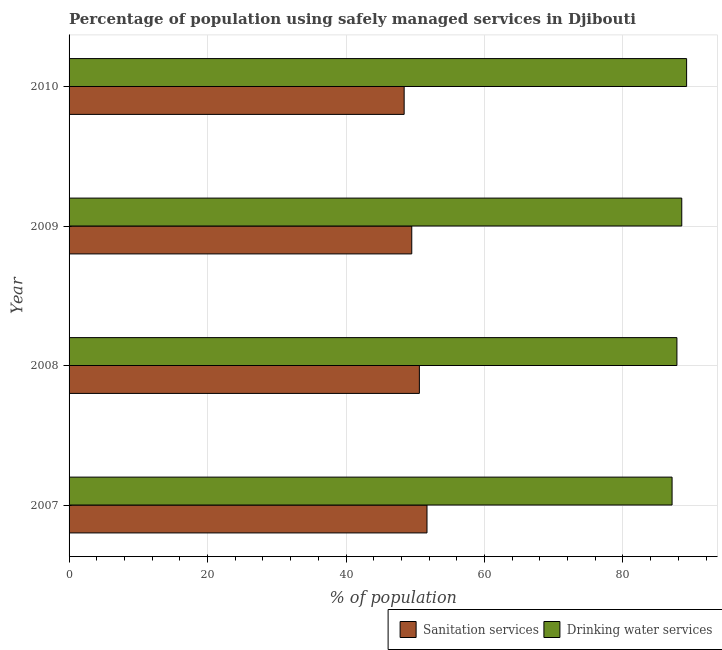How many groups of bars are there?
Give a very brief answer. 4. Are the number of bars per tick equal to the number of legend labels?
Ensure brevity in your answer.  Yes. Are the number of bars on each tick of the Y-axis equal?
Your answer should be compact. Yes. How many bars are there on the 3rd tick from the top?
Offer a terse response. 2. How many bars are there on the 1st tick from the bottom?
Your response must be concise. 2. What is the label of the 3rd group of bars from the top?
Keep it short and to the point. 2008. What is the percentage of population who used sanitation services in 2007?
Ensure brevity in your answer.  51.7. Across all years, what is the maximum percentage of population who used drinking water services?
Offer a very short reply. 89.2. Across all years, what is the minimum percentage of population who used drinking water services?
Your response must be concise. 87.1. In which year was the percentage of population who used sanitation services maximum?
Provide a short and direct response. 2007. What is the total percentage of population who used drinking water services in the graph?
Keep it short and to the point. 352.6. What is the difference between the percentage of population who used drinking water services in 2010 and the percentage of population who used sanitation services in 2007?
Your response must be concise. 37.5. What is the average percentage of population who used sanitation services per year?
Offer a terse response. 50.05. In the year 2008, what is the difference between the percentage of population who used sanitation services and percentage of population who used drinking water services?
Give a very brief answer. -37.2. What is the ratio of the percentage of population who used sanitation services in 2007 to that in 2008?
Give a very brief answer. 1.02. What is the difference between the highest and the second highest percentage of population who used drinking water services?
Make the answer very short. 0.7. What does the 2nd bar from the top in 2008 represents?
Offer a terse response. Sanitation services. What does the 1st bar from the bottom in 2009 represents?
Your response must be concise. Sanitation services. Are all the bars in the graph horizontal?
Offer a very short reply. Yes. Are the values on the major ticks of X-axis written in scientific E-notation?
Give a very brief answer. No. Does the graph contain grids?
Give a very brief answer. Yes. How are the legend labels stacked?
Offer a terse response. Horizontal. What is the title of the graph?
Offer a terse response. Percentage of population using safely managed services in Djibouti. What is the label or title of the X-axis?
Your answer should be compact. % of population. What is the label or title of the Y-axis?
Provide a succinct answer. Year. What is the % of population of Sanitation services in 2007?
Your answer should be very brief. 51.7. What is the % of population in Drinking water services in 2007?
Offer a terse response. 87.1. What is the % of population in Sanitation services in 2008?
Your answer should be compact. 50.6. What is the % of population of Drinking water services in 2008?
Provide a succinct answer. 87.8. What is the % of population in Sanitation services in 2009?
Make the answer very short. 49.5. What is the % of population in Drinking water services in 2009?
Provide a short and direct response. 88.5. What is the % of population in Sanitation services in 2010?
Offer a very short reply. 48.4. What is the % of population in Drinking water services in 2010?
Provide a short and direct response. 89.2. Across all years, what is the maximum % of population in Sanitation services?
Provide a succinct answer. 51.7. Across all years, what is the maximum % of population of Drinking water services?
Provide a short and direct response. 89.2. Across all years, what is the minimum % of population of Sanitation services?
Offer a terse response. 48.4. Across all years, what is the minimum % of population of Drinking water services?
Make the answer very short. 87.1. What is the total % of population in Sanitation services in the graph?
Ensure brevity in your answer.  200.2. What is the total % of population in Drinking water services in the graph?
Provide a succinct answer. 352.6. What is the difference between the % of population in Sanitation services in 2007 and that in 2008?
Keep it short and to the point. 1.1. What is the difference between the % of population in Sanitation services in 2007 and that in 2009?
Keep it short and to the point. 2.2. What is the difference between the % of population of Drinking water services in 2007 and that in 2009?
Your answer should be very brief. -1.4. What is the difference between the % of population of Sanitation services in 2008 and that in 2009?
Provide a short and direct response. 1.1. What is the difference between the % of population in Drinking water services in 2008 and that in 2009?
Ensure brevity in your answer.  -0.7. What is the difference between the % of population of Sanitation services in 2008 and that in 2010?
Your response must be concise. 2.2. What is the difference between the % of population of Drinking water services in 2008 and that in 2010?
Make the answer very short. -1.4. What is the difference between the % of population of Sanitation services in 2007 and the % of population of Drinking water services in 2008?
Provide a short and direct response. -36.1. What is the difference between the % of population of Sanitation services in 2007 and the % of population of Drinking water services in 2009?
Your response must be concise. -36.8. What is the difference between the % of population in Sanitation services in 2007 and the % of population in Drinking water services in 2010?
Your answer should be compact. -37.5. What is the difference between the % of population of Sanitation services in 2008 and the % of population of Drinking water services in 2009?
Keep it short and to the point. -37.9. What is the difference between the % of population of Sanitation services in 2008 and the % of population of Drinking water services in 2010?
Your answer should be compact. -38.6. What is the difference between the % of population in Sanitation services in 2009 and the % of population in Drinking water services in 2010?
Your answer should be very brief. -39.7. What is the average % of population of Sanitation services per year?
Ensure brevity in your answer.  50.05. What is the average % of population in Drinking water services per year?
Provide a short and direct response. 88.15. In the year 2007, what is the difference between the % of population in Sanitation services and % of population in Drinking water services?
Give a very brief answer. -35.4. In the year 2008, what is the difference between the % of population of Sanitation services and % of population of Drinking water services?
Make the answer very short. -37.2. In the year 2009, what is the difference between the % of population in Sanitation services and % of population in Drinking water services?
Ensure brevity in your answer.  -39. In the year 2010, what is the difference between the % of population of Sanitation services and % of population of Drinking water services?
Offer a terse response. -40.8. What is the ratio of the % of population of Sanitation services in 2007 to that in 2008?
Keep it short and to the point. 1.02. What is the ratio of the % of population in Sanitation services in 2007 to that in 2009?
Your response must be concise. 1.04. What is the ratio of the % of population in Drinking water services in 2007 to that in 2009?
Your answer should be very brief. 0.98. What is the ratio of the % of population of Sanitation services in 2007 to that in 2010?
Provide a short and direct response. 1.07. What is the ratio of the % of population of Drinking water services in 2007 to that in 2010?
Provide a succinct answer. 0.98. What is the ratio of the % of population in Sanitation services in 2008 to that in 2009?
Offer a very short reply. 1.02. What is the ratio of the % of population in Sanitation services in 2008 to that in 2010?
Ensure brevity in your answer.  1.05. What is the ratio of the % of population in Drinking water services in 2008 to that in 2010?
Your answer should be very brief. 0.98. What is the ratio of the % of population of Sanitation services in 2009 to that in 2010?
Ensure brevity in your answer.  1.02. What is the difference between the highest and the second highest % of population of Sanitation services?
Your answer should be very brief. 1.1. What is the difference between the highest and the second highest % of population of Drinking water services?
Provide a succinct answer. 0.7. What is the difference between the highest and the lowest % of population in Sanitation services?
Your response must be concise. 3.3. 